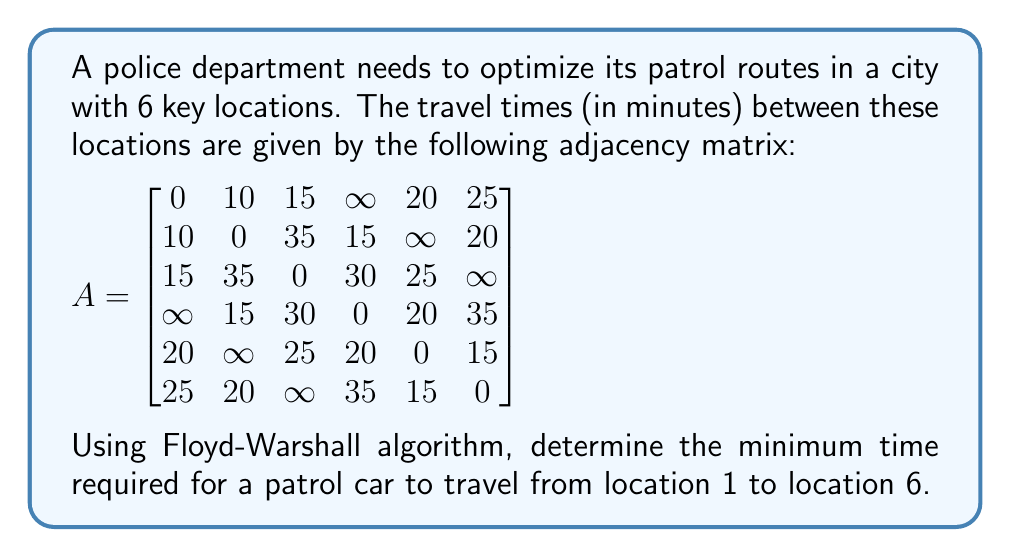Give your solution to this math problem. To solve this problem, we'll use the Floyd-Warshall algorithm to find the shortest path between all pairs of vertices in the graph. The algorithm works as follows:

1. Initialize the distance matrix D with the given adjacency matrix A.
2. For each intermediate vertex k = 1 to 6:
   For each pair of vertices (i, j):
   Update D[i][j] = min(D[i][j], D[i][k] + D[k][j])

3. After the algorithm completes, D[i][j] will contain the shortest distance from i to j.

Let's apply the algorithm:

Step 1: Initialize D = A

Step 2: Iterate through k = 1 to 6

For k = 1, no changes occur as it's already optimal.

For k = 2:
D[1][4] = min(∞, 10 + 15) = 25
D[4][1] = 25

For k = 3:
No changes

For k = 4:
D[1][2] = min(10, 25 + 15) = 10 (no change)
D[1][5] = min(20, 25 + 20) = 20 (no change)

For k = 5:
D[1][6] = min(25, 20 + 15) = 25 (no change)
D[2][3] = min(35, ∞ + 25) = 35 (no change)

For k = 6:
No changes

After completing the algorithm, the shortest path from location 1 to location 6 is found in D[1][6] = 25.
Answer: 25 minutes 